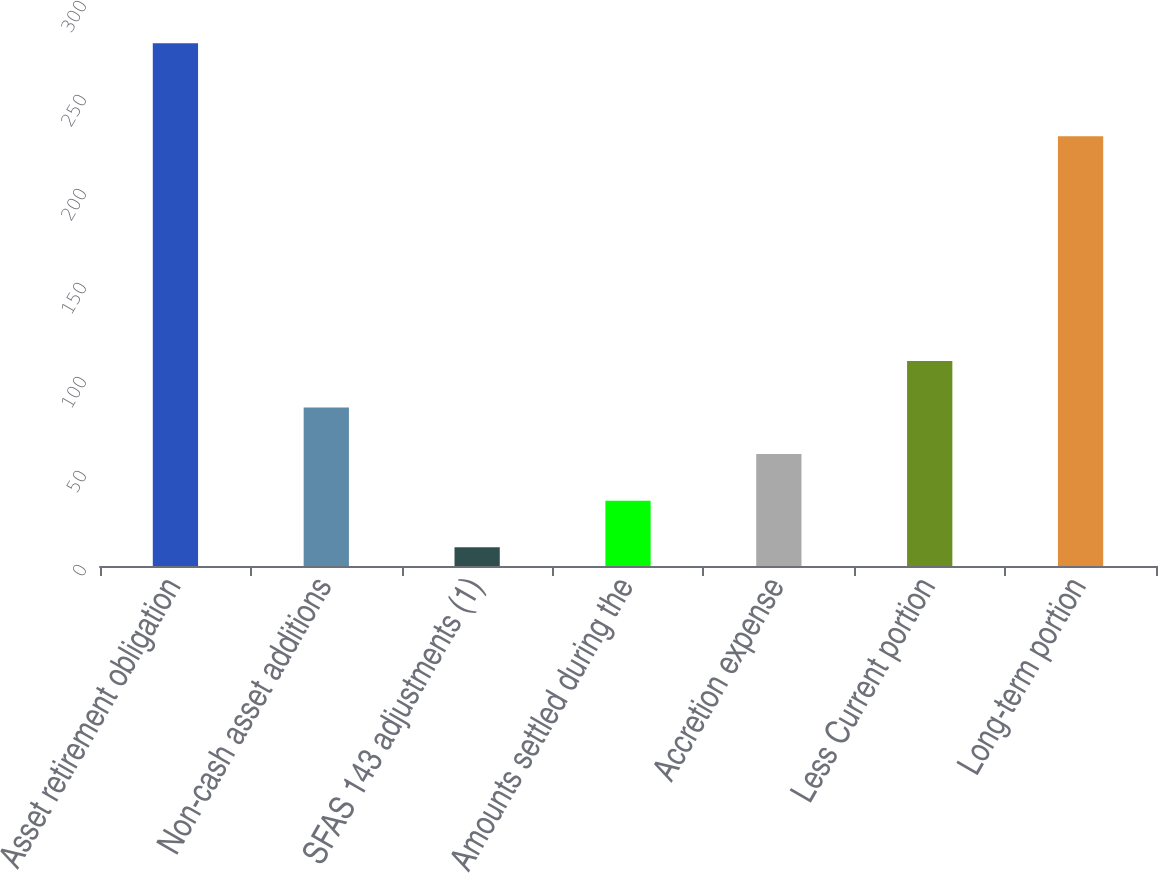Convert chart to OTSL. <chart><loc_0><loc_0><loc_500><loc_500><bar_chart><fcel>Asset retirement obligation<fcel>Non-cash asset additions<fcel>SFAS 143 adjustments (1)<fcel>Amounts settled during the<fcel>Accretion expense<fcel>Less Current portion<fcel>Long-term portion<nl><fcel>278.12<fcel>84.28<fcel>10<fcel>34.76<fcel>59.52<fcel>109.04<fcel>228.6<nl></chart> 